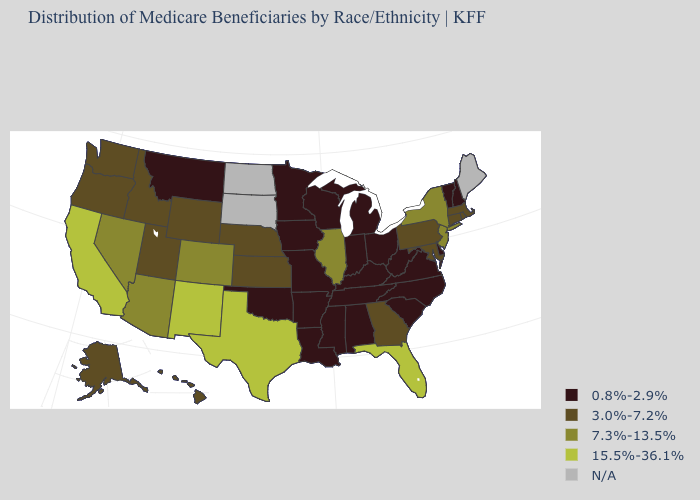What is the value of Rhode Island?
Write a very short answer. 3.0%-7.2%. Name the states that have a value in the range 0.8%-2.9%?
Write a very short answer. Alabama, Arkansas, Delaware, Indiana, Iowa, Kentucky, Louisiana, Michigan, Minnesota, Mississippi, Missouri, Montana, New Hampshire, North Carolina, Ohio, Oklahoma, South Carolina, Tennessee, Vermont, Virginia, West Virginia, Wisconsin. What is the value of Georgia?
Be succinct. 3.0%-7.2%. What is the lowest value in the MidWest?
Be succinct. 0.8%-2.9%. What is the value of New Jersey?
Give a very brief answer. 7.3%-13.5%. Name the states that have a value in the range 3.0%-7.2%?
Give a very brief answer. Alaska, Connecticut, Georgia, Hawaii, Idaho, Kansas, Maryland, Massachusetts, Nebraska, Oregon, Pennsylvania, Rhode Island, Utah, Washington, Wyoming. What is the value of Kansas?
Give a very brief answer. 3.0%-7.2%. What is the lowest value in states that border Maryland?
Write a very short answer. 0.8%-2.9%. Name the states that have a value in the range N/A?
Short answer required. Maine, North Dakota, South Dakota. Name the states that have a value in the range 0.8%-2.9%?
Short answer required. Alabama, Arkansas, Delaware, Indiana, Iowa, Kentucky, Louisiana, Michigan, Minnesota, Mississippi, Missouri, Montana, New Hampshire, North Carolina, Ohio, Oklahoma, South Carolina, Tennessee, Vermont, Virginia, West Virginia, Wisconsin. Which states have the lowest value in the USA?
Be succinct. Alabama, Arkansas, Delaware, Indiana, Iowa, Kentucky, Louisiana, Michigan, Minnesota, Mississippi, Missouri, Montana, New Hampshire, North Carolina, Ohio, Oklahoma, South Carolina, Tennessee, Vermont, Virginia, West Virginia, Wisconsin. Does the map have missing data?
Keep it brief. Yes. What is the lowest value in states that border South Carolina?
Be succinct. 0.8%-2.9%. What is the highest value in the USA?
Keep it brief. 15.5%-36.1%. 